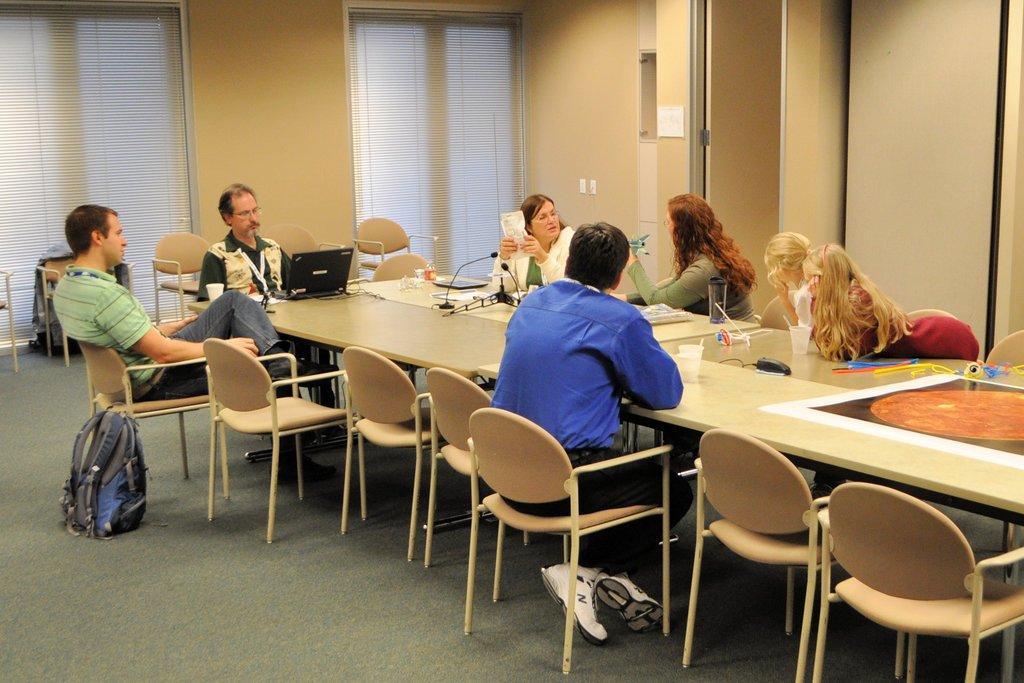Please provide a concise description of this image. On the right a man is sitting in the chair. He wears a blue color shirt on the left few people are sitting on the chair and opposite to them four girls are sitting on the chair there is a door behind them. 